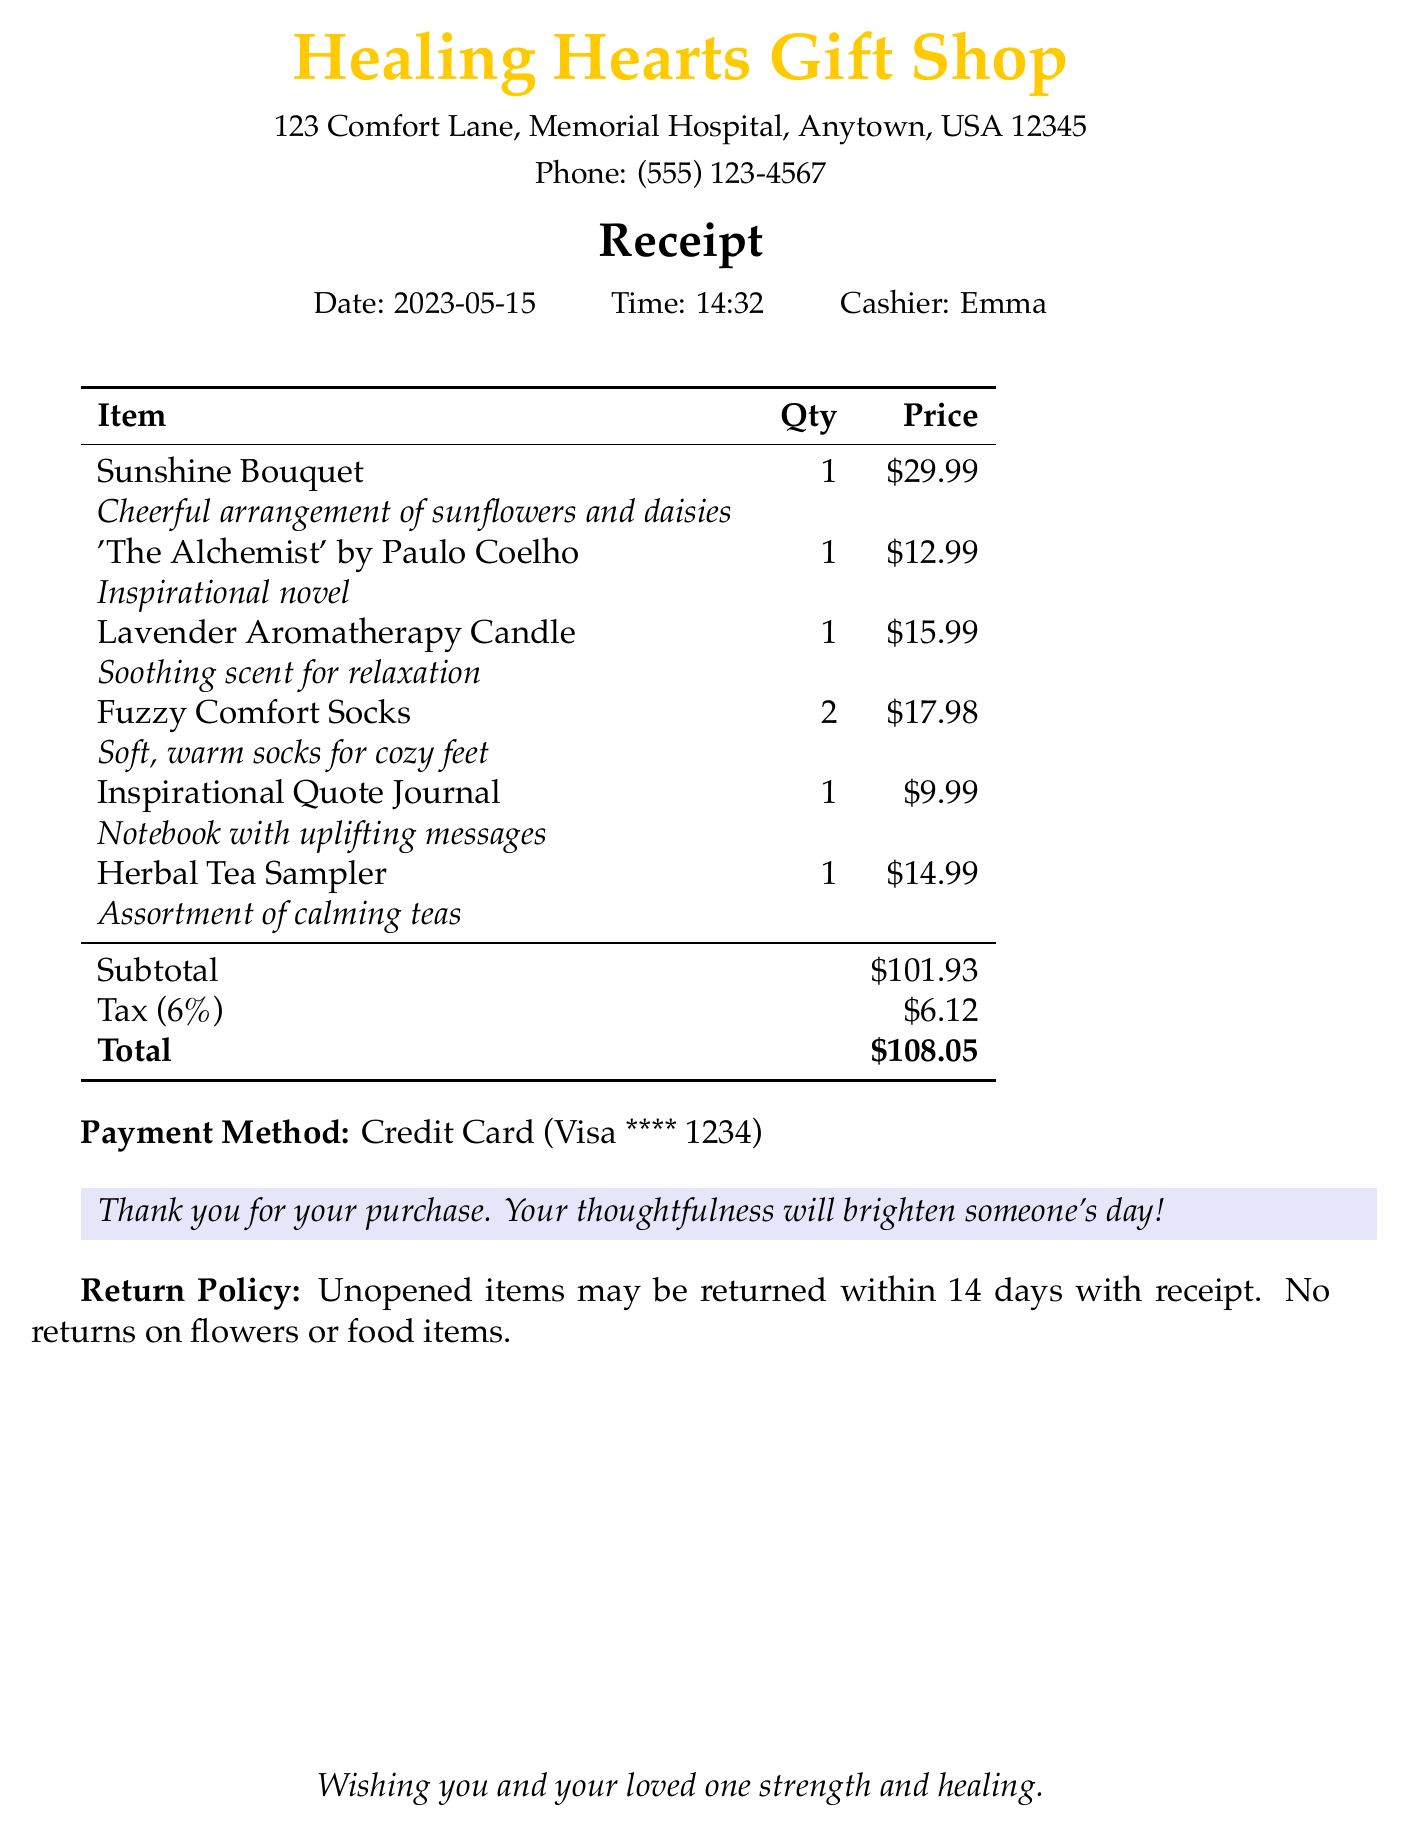what is the name of the store? The name of the store is listed at the top of the receipt as "Healing Hearts Gift Shop."
Answer: Healing Hearts Gift Shop who is the cashier? The cashier's name is mentioned in the receipt details, which is "Emma."
Answer: Emma what is the total amount spent? The total amount is calculated at the end of the receipt and is shown as "$108.05."
Answer: $108.05 how many items were purchased in total? The total number of items can be counted from the list provided on the receipt, which includes six entries with quantities.
Answer: 6 what is the return policy for unopened items? The return policy states that "Unopened items may be returned within 14 days with receipt."
Answer: 14 days what type of payment method was used? The payment method is indicated at the bottom of the receipt as "Credit Card."
Answer: Credit Card which flower arrangement was bought? The receipt lists a specific flower arrangement, which is "Sunshine Bouquet."
Answer: Sunshine Bouquet how many pairs of Fuzzy Comfort Socks were purchased? The quantity for Fuzzy Comfort Socks is specified in the item list, which shows "2."
Answer: 2 what is the description of the Lavender Aromatherapy Candle? The description given in the receipt states it is for "Soothing scent for relaxation."
Answer: Soothing scent for relaxation 